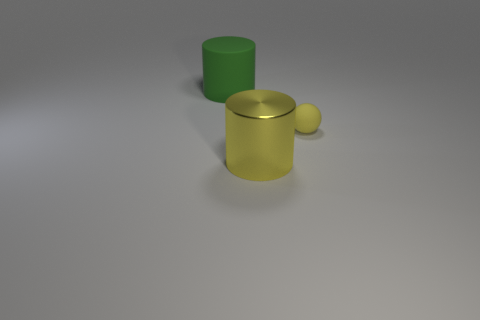Is there anything else that is the same material as the yellow cylinder?
Give a very brief answer. No. What is the size of the green thing that is the same shape as the yellow shiny object?
Provide a short and direct response. Large. What shape is the big yellow metal thing that is on the right side of the matte object behind the yellow ball?
Ensure brevity in your answer.  Cylinder. What number of yellow things are small matte cylinders or small matte balls?
Your answer should be compact. 1. The matte sphere has what color?
Your answer should be very brief. Yellow. Do the matte cylinder and the rubber ball have the same size?
Provide a short and direct response. No. Is there any other thing that is the same shape as the tiny rubber object?
Provide a succinct answer. No. Do the green cylinder and the large cylinder right of the large green thing have the same material?
Provide a succinct answer. No. Do the matte object right of the green cylinder and the big matte thing have the same color?
Your answer should be compact. No. How many objects are on the left side of the ball and behind the large yellow metal cylinder?
Offer a very short reply. 1. 